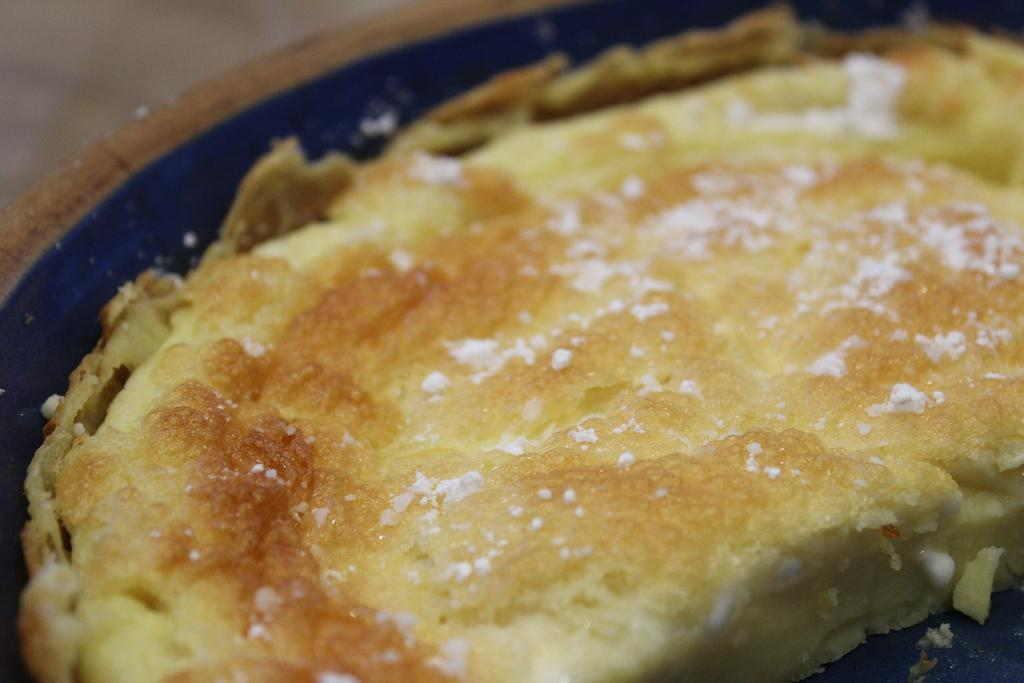What color is the main object in the image? The main object in the image is blue. What is inside the blue object? The blue object contains a food item. Where is the blue object located in the image? The blue object is in the center of the image. How many stems can be seen growing from the blue object in the image? There are no stems visible in the image, as the blue object contains a food item and is not a plant. 